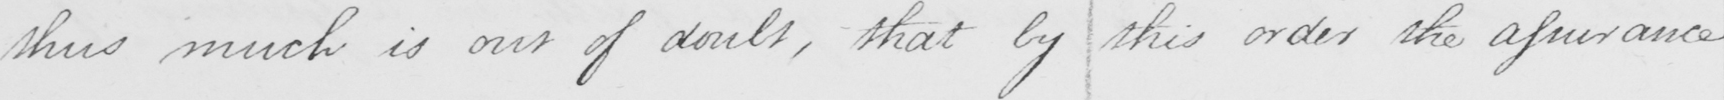Transcribe the text shown in this historical manuscript line. thus much is our doubt , that by this order the assurance 